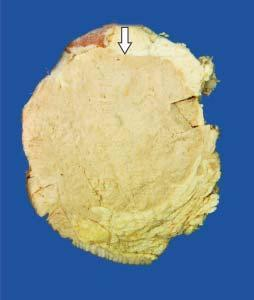s examination of bone marrow somewhat delineated from the adjacent breast parenchyma as compared to irregular margin of idc?
Answer the question using a single word or phrase. No 